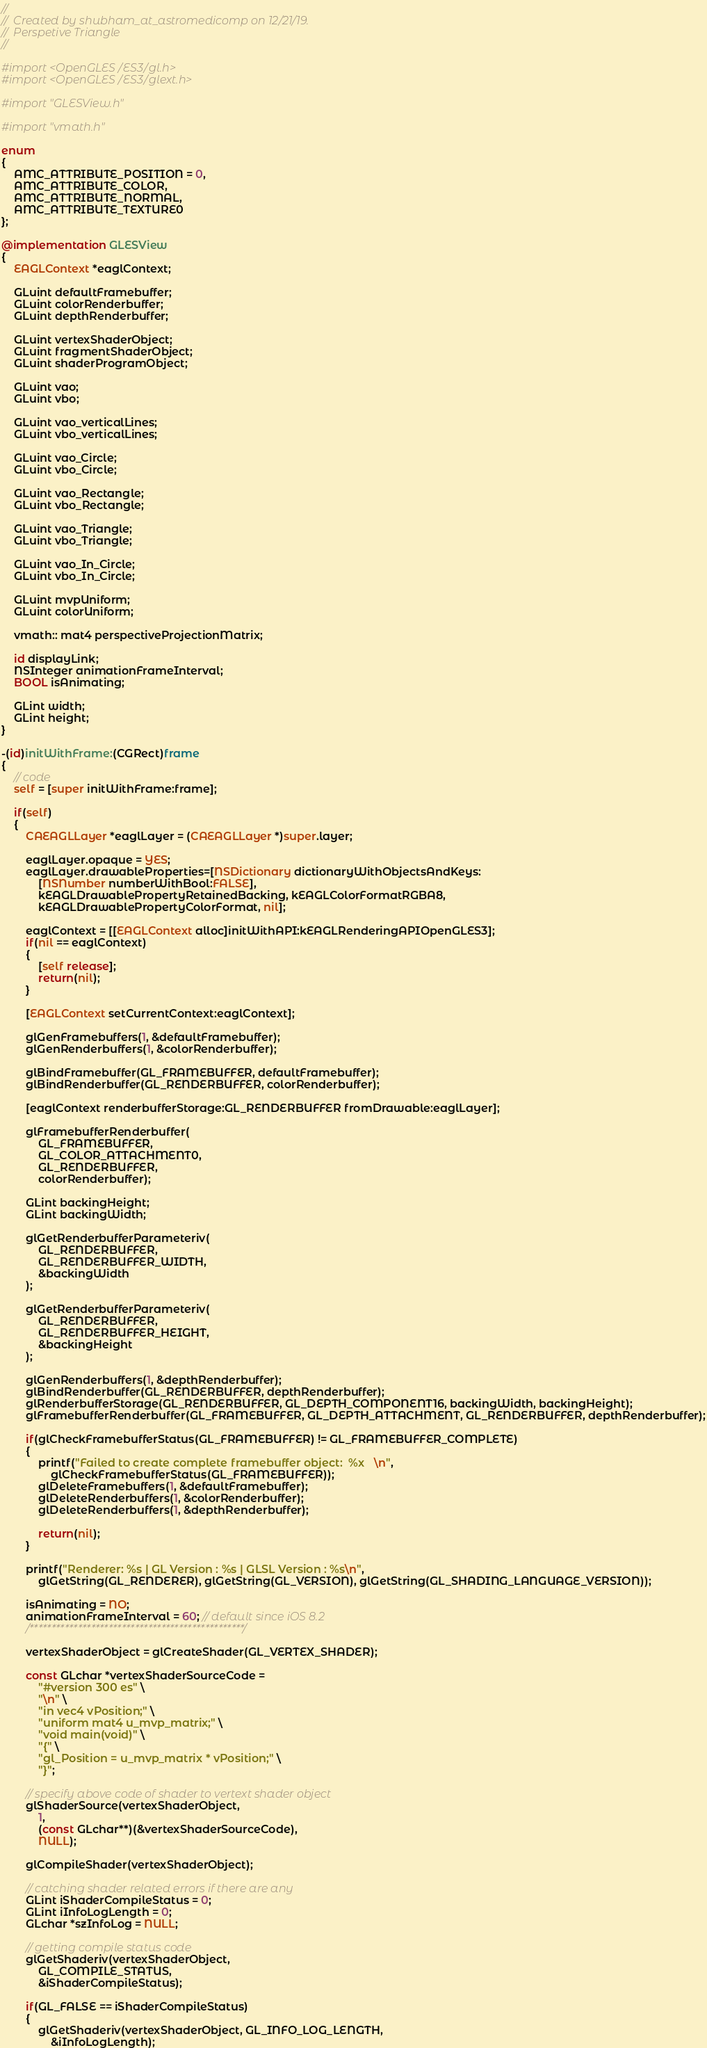Convert code to text. <code><loc_0><loc_0><loc_500><loc_500><_ObjectiveC_>//
//  Created by shubham_at_astromedicomp on 12/21/19.
//  Perspetive Triangle
//

#import <OpenGLES/ES3/gl.h>
#import <OpenGLES/ES3/glext.h>

#import "GLESView.h"

#import "vmath.h"

enum
{
    AMC_ATTRIBUTE_POSITION = 0,
    AMC_ATTRIBUTE_COLOR,
    AMC_ATTRIBUTE_NORMAL,
    AMC_ATTRIBUTE_TEXTURE0
};

@implementation GLESView
{
    EAGLContext *eaglContext;

    GLuint defaultFramebuffer;
    GLuint colorRenderbuffer;
    GLuint depthRenderbuffer;

    GLuint vertexShaderObject;
    GLuint fragmentShaderObject;
    GLuint shaderProgramObject;

    GLuint vao;
    GLuint vbo;

    GLuint vao_verticalLines;
    GLuint vbo_verticalLines;

    GLuint vao_Circle;
    GLuint vbo_Circle;

    GLuint vao_Rectangle;
    GLuint vbo_Rectangle;

    GLuint vao_Triangle;
    GLuint vbo_Triangle;

    GLuint vao_In_Circle;
    GLuint vbo_In_Circle;

    GLuint mvpUniform;
    GLuint colorUniform;

    vmath:: mat4 perspectiveProjectionMatrix;

    id displayLink;
    NSInteger animationFrameInterval;
    BOOL isAnimating;

    GLint width;
    GLint height;
}

-(id)initWithFrame:(CGRect)frame
{
    // code
    self = [super initWithFrame:frame];

    if(self)
    {
        CAEAGLLayer *eaglLayer = (CAEAGLLayer *)super.layer;

        eaglLayer.opaque = YES;
        eaglLayer.drawableProperties=[NSDictionary dictionaryWithObjectsAndKeys:
            [NSNumber numberWithBool:FALSE],
            kEAGLDrawablePropertyRetainedBacking, kEAGLColorFormatRGBA8,
            kEAGLDrawablePropertyColorFormat, nil];

        eaglContext = [[EAGLContext alloc]initWithAPI:kEAGLRenderingAPIOpenGLES3];
        if(nil == eaglContext)
        {
            [self release];
            return(nil);
        }

        [EAGLContext setCurrentContext:eaglContext];

        glGenFramebuffers(1, &defaultFramebuffer);
        glGenRenderbuffers(1, &colorRenderbuffer);

        glBindFramebuffer(GL_FRAMEBUFFER, defaultFramebuffer);
        glBindRenderbuffer(GL_RENDERBUFFER, colorRenderbuffer);

        [eaglContext renderbufferStorage:GL_RENDERBUFFER fromDrawable:eaglLayer];

        glFramebufferRenderbuffer(
            GL_FRAMEBUFFER,
            GL_COLOR_ATTACHMENT0,
            GL_RENDERBUFFER,
            colorRenderbuffer);

        GLint backingHeight;
        GLint backingWidth;

        glGetRenderbufferParameteriv(
            GL_RENDERBUFFER,
            GL_RENDERBUFFER_WIDTH,
            &backingWidth
        );

        glGetRenderbufferParameteriv(
            GL_RENDERBUFFER,
            GL_RENDERBUFFER_HEIGHT,
            &backingHeight
        );

        glGenRenderbuffers(1, &depthRenderbuffer);
        glBindRenderbuffer(GL_RENDERBUFFER, depthRenderbuffer);
        glRenderbufferStorage(GL_RENDERBUFFER, GL_DEPTH_COMPONENT16, backingWidth, backingHeight);
        glFramebufferRenderbuffer(GL_FRAMEBUFFER, GL_DEPTH_ATTACHMENT, GL_RENDERBUFFER, depthRenderbuffer);

        if(glCheckFramebufferStatus(GL_FRAMEBUFFER) != GL_FRAMEBUFFER_COMPLETE)
        {
            printf("Failed to create complete framebuffer object:  %x   \n",
                glCheckFramebufferStatus(GL_FRAMEBUFFER));
            glDeleteFramebuffers(1, &defaultFramebuffer);
            glDeleteRenderbuffers(1, &colorRenderbuffer);
            glDeleteRenderbuffers(1, &depthRenderbuffer);

            return(nil);
        }

        printf("Renderer: %s | GL Version : %s | GLSL Version : %s\n",
            glGetString(GL_RENDERER), glGetString(GL_VERSION), glGetString(GL_SHADING_LANGUAGE_VERSION));

        isAnimating = NO;
        animationFrameInterval = 60; // default since iOS 8.2
        /*************************************************/

        vertexShaderObject = glCreateShader(GL_VERTEX_SHADER);

        const GLchar *vertexShaderSourceCode =
            "#version 300 es" \
            "\n" \
            "in vec4 vPosition;" \
            "uniform mat4 u_mvp_matrix;" \
            "void main(void)" \
            "{" \
            "gl_Position = u_mvp_matrix * vPosition;" \
            "}";

        // specify above code of shader to vertext shader object
        glShaderSource(vertexShaderObject,
            1,
            (const GLchar**)(&vertexShaderSourceCode),
            NULL);

        glCompileShader(vertexShaderObject);

        // catching shader related errors if there are any
        GLint iShaderCompileStatus = 0;
        GLint iInfoLogLength = 0;
        GLchar *szInfoLog = NULL;

        // getting compile status code
        glGetShaderiv(vertexShaderObject,
            GL_COMPILE_STATUS,
            &iShaderCompileStatus);

        if(GL_FALSE == iShaderCompileStatus)
        {
            glGetShaderiv(vertexShaderObject, GL_INFO_LOG_LENGTH,
                &iInfoLogLength);</code> 